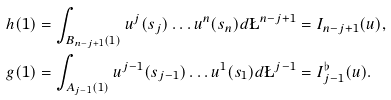Convert formula to latex. <formula><loc_0><loc_0><loc_500><loc_500>h ( 1 ) & = \int _ { B _ { n - j + 1 } ( 1 ) } u ^ { j } ( s _ { j } ) \dots u ^ { n } ( s _ { n } ) d \L ^ { n - j + 1 } = I _ { n - j + 1 } ( u ) , \\ g ( 1 ) & = \int _ { A _ { j - 1 } ( 1 ) } u ^ { j - 1 } ( s _ { j - 1 } ) \dots u ^ { 1 } ( s _ { 1 } ) d \L ^ { j - 1 } = I ^ { \flat } _ { j - 1 } ( u ) .</formula> 